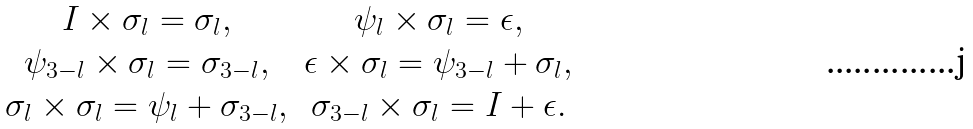<formula> <loc_0><loc_0><loc_500><loc_500>\begin{array} { c c } I \times \sigma _ { l } = \sigma _ { l } , & \psi _ { l } \times \sigma _ { l } = \epsilon , \\ \psi _ { 3 - l } \times \sigma _ { l } = \sigma _ { 3 - l } , & \epsilon \times \sigma _ { l } = \psi _ { 3 - l } + \sigma _ { l } , \\ \sigma _ { l } \times \sigma _ { l } = \psi _ { l } + \sigma _ { 3 - l } , & \sigma _ { 3 - l } \times \sigma _ { l } = I + \epsilon . \end{array}</formula> 